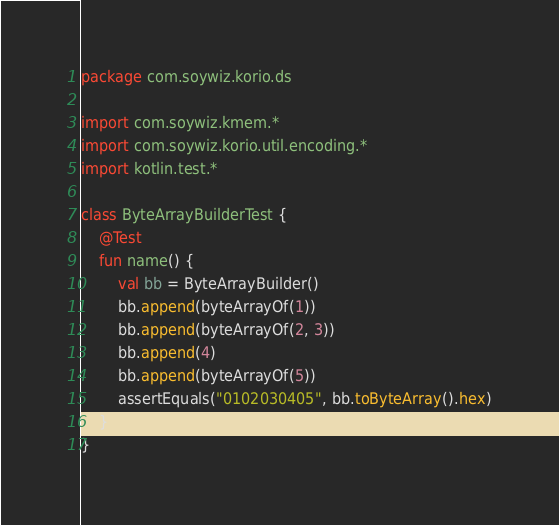Convert code to text. <code><loc_0><loc_0><loc_500><loc_500><_Kotlin_>package com.soywiz.korio.ds

import com.soywiz.kmem.*
import com.soywiz.korio.util.encoding.*
import kotlin.test.*

class ByteArrayBuilderTest {
	@Test
	fun name() {
		val bb = ByteArrayBuilder()
		bb.append(byteArrayOf(1))
		bb.append(byteArrayOf(2, 3))
		bb.append(4)
		bb.append(byteArrayOf(5))
		assertEquals("0102030405", bb.toByteArray().hex)
	}
}</code> 